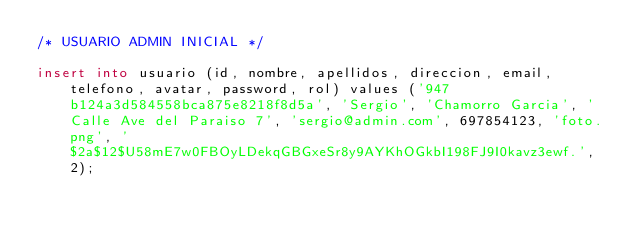Convert code to text. <code><loc_0><loc_0><loc_500><loc_500><_SQL_>/* USUARIO ADMIN INICIAL */

insert into usuario (id, nombre, apellidos, direccion, email, telefono, avatar, password, rol) values ('947b124a3d584558bca875e8218f8d5a', 'Sergio', 'Chamorro Garcia', 'Calle Ave del Paraiso 7', 'sergio@admin.com', 697854123, 'foto.png', '$2a$12$U58mE7w0FBOyLDekqGBGxeSr8y9AYKhOGkbI198FJ9I0kavz3ewf.', 2);
</code> 